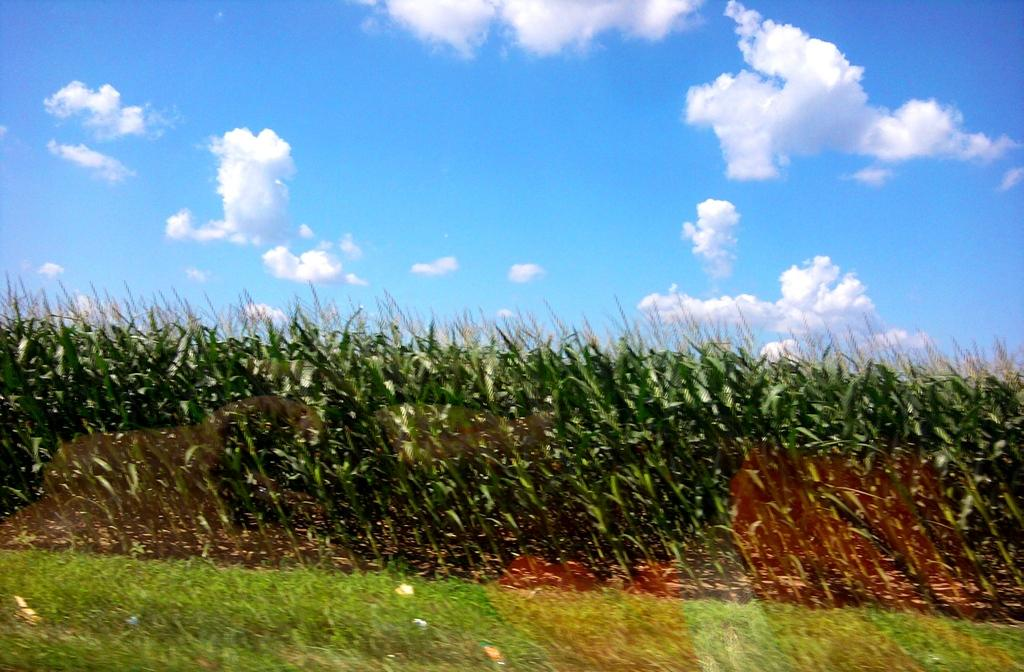What type of plants can be seen in the image? There are many crops in the image. What is the ground cover in front of the crops? There is grass in front of the crops. From where was the image captured? The image is captured from behind the grass. What type of belief system is represented by the crops in the image? There is no indication of any belief system in the image; it simply shows crops and grass. 